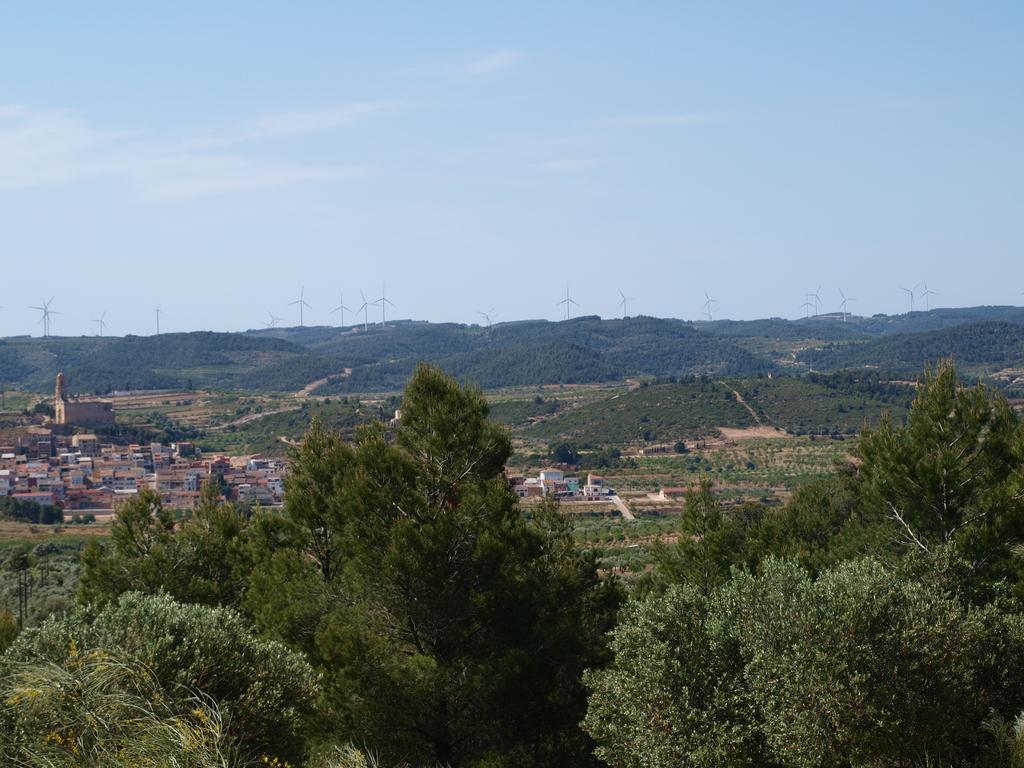Please provide a concise description of this image. In this image we can see trees, ground, houses, and windmills. In the background there is sky. 